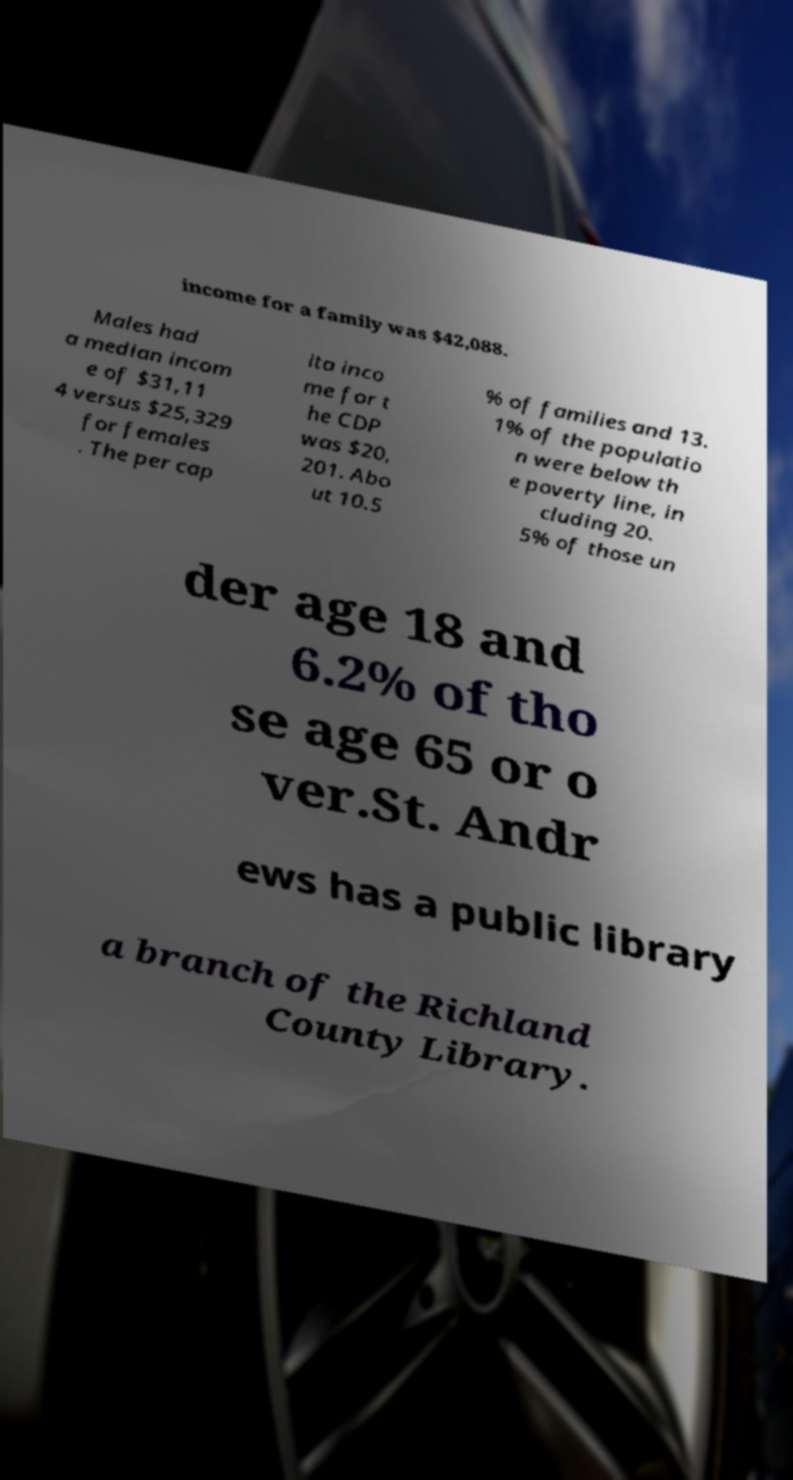Can you accurately transcribe the text from the provided image for me? income for a family was $42,088. Males had a median incom e of $31,11 4 versus $25,329 for females . The per cap ita inco me for t he CDP was $20, 201. Abo ut 10.5 % of families and 13. 1% of the populatio n were below th e poverty line, in cluding 20. 5% of those un der age 18 and 6.2% of tho se age 65 or o ver.St. Andr ews has a public library a branch of the Richland County Library. 